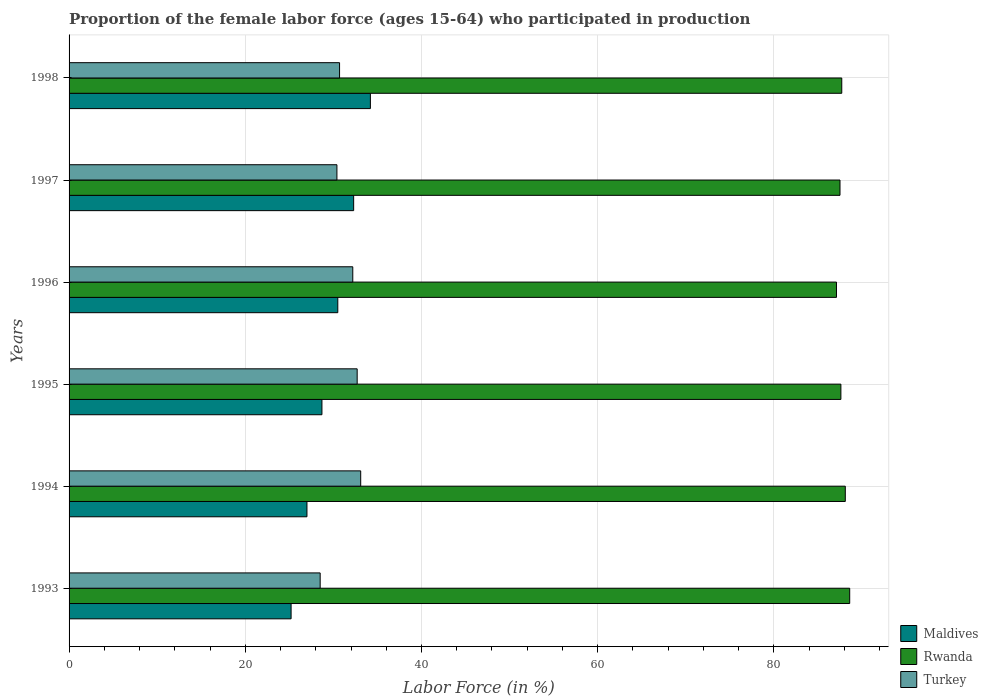How many different coloured bars are there?
Your answer should be compact. 3. How many groups of bars are there?
Provide a succinct answer. 6. What is the label of the 2nd group of bars from the top?
Make the answer very short. 1997. What is the proportion of the female labor force who participated in production in Maldives in 1993?
Offer a terse response. 25.2. Across all years, what is the maximum proportion of the female labor force who participated in production in Maldives?
Your response must be concise. 34.2. Across all years, what is the minimum proportion of the female labor force who participated in production in Turkey?
Provide a succinct answer. 28.5. In which year was the proportion of the female labor force who participated in production in Rwanda maximum?
Provide a short and direct response. 1993. In which year was the proportion of the female labor force who participated in production in Maldives minimum?
Keep it short and to the point. 1993. What is the total proportion of the female labor force who participated in production in Turkey in the graph?
Your answer should be very brief. 187.6. What is the difference between the proportion of the female labor force who participated in production in Turkey in 1995 and that in 1998?
Offer a very short reply. 2. What is the difference between the proportion of the female labor force who participated in production in Maldives in 1997 and the proportion of the female labor force who participated in production in Rwanda in 1998?
Provide a succinct answer. -55.4. What is the average proportion of the female labor force who participated in production in Maldives per year?
Your answer should be compact. 29.65. In the year 1998, what is the difference between the proportion of the female labor force who participated in production in Turkey and proportion of the female labor force who participated in production in Rwanda?
Offer a terse response. -57. In how many years, is the proportion of the female labor force who participated in production in Rwanda greater than 64 %?
Your answer should be very brief. 6. What is the ratio of the proportion of the female labor force who participated in production in Rwanda in 1993 to that in 1998?
Provide a succinct answer. 1.01. What is the difference between the highest and the second highest proportion of the female labor force who participated in production in Maldives?
Offer a terse response. 1.9. What is the difference between the highest and the lowest proportion of the female labor force who participated in production in Maldives?
Your answer should be compact. 9. In how many years, is the proportion of the female labor force who participated in production in Turkey greater than the average proportion of the female labor force who participated in production in Turkey taken over all years?
Your answer should be compact. 3. What does the 3rd bar from the top in 1994 represents?
Your answer should be compact. Maldives. What does the 1st bar from the bottom in 1994 represents?
Provide a succinct answer. Maldives. Is it the case that in every year, the sum of the proportion of the female labor force who participated in production in Maldives and proportion of the female labor force who participated in production in Turkey is greater than the proportion of the female labor force who participated in production in Rwanda?
Provide a short and direct response. No. How many bars are there?
Provide a short and direct response. 18. How many years are there in the graph?
Offer a very short reply. 6. What is the difference between two consecutive major ticks on the X-axis?
Your answer should be very brief. 20. Where does the legend appear in the graph?
Keep it short and to the point. Bottom right. How many legend labels are there?
Keep it short and to the point. 3. What is the title of the graph?
Your answer should be very brief. Proportion of the female labor force (ages 15-64) who participated in production. Does "Israel" appear as one of the legend labels in the graph?
Offer a terse response. No. What is the label or title of the Y-axis?
Your response must be concise. Years. What is the Labor Force (in %) in Maldives in 1993?
Provide a short and direct response. 25.2. What is the Labor Force (in %) of Rwanda in 1993?
Your answer should be very brief. 88.6. What is the Labor Force (in %) of Rwanda in 1994?
Ensure brevity in your answer.  88.1. What is the Labor Force (in %) of Turkey in 1994?
Offer a terse response. 33.1. What is the Labor Force (in %) in Maldives in 1995?
Ensure brevity in your answer.  28.7. What is the Labor Force (in %) in Rwanda in 1995?
Your answer should be very brief. 87.6. What is the Labor Force (in %) in Turkey in 1995?
Make the answer very short. 32.7. What is the Labor Force (in %) in Maldives in 1996?
Ensure brevity in your answer.  30.5. What is the Labor Force (in %) in Rwanda in 1996?
Your response must be concise. 87.1. What is the Labor Force (in %) of Turkey in 1996?
Your answer should be compact. 32.2. What is the Labor Force (in %) of Maldives in 1997?
Your response must be concise. 32.3. What is the Labor Force (in %) in Rwanda in 1997?
Give a very brief answer. 87.5. What is the Labor Force (in %) of Turkey in 1997?
Your answer should be very brief. 30.4. What is the Labor Force (in %) of Maldives in 1998?
Provide a short and direct response. 34.2. What is the Labor Force (in %) in Rwanda in 1998?
Your answer should be very brief. 87.7. What is the Labor Force (in %) of Turkey in 1998?
Your answer should be very brief. 30.7. Across all years, what is the maximum Labor Force (in %) in Maldives?
Your response must be concise. 34.2. Across all years, what is the maximum Labor Force (in %) of Rwanda?
Offer a very short reply. 88.6. Across all years, what is the maximum Labor Force (in %) in Turkey?
Offer a very short reply. 33.1. Across all years, what is the minimum Labor Force (in %) of Maldives?
Your answer should be compact. 25.2. Across all years, what is the minimum Labor Force (in %) of Rwanda?
Provide a short and direct response. 87.1. Across all years, what is the minimum Labor Force (in %) in Turkey?
Your response must be concise. 28.5. What is the total Labor Force (in %) of Maldives in the graph?
Make the answer very short. 177.9. What is the total Labor Force (in %) in Rwanda in the graph?
Offer a terse response. 526.6. What is the total Labor Force (in %) of Turkey in the graph?
Provide a short and direct response. 187.6. What is the difference between the Labor Force (in %) in Rwanda in 1993 and that in 1994?
Your answer should be compact. 0.5. What is the difference between the Labor Force (in %) of Turkey in 1993 and that in 1994?
Provide a short and direct response. -4.6. What is the difference between the Labor Force (in %) in Rwanda in 1993 and that in 1995?
Offer a terse response. 1. What is the difference between the Labor Force (in %) in Turkey in 1993 and that in 1995?
Offer a very short reply. -4.2. What is the difference between the Labor Force (in %) in Maldives in 1993 and that in 1996?
Make the answer very short. -5.3. What is the difference between the Labor Force (in %) in Maldives in 1993 and that in 1997?
Provide a short and direct response. -7.1. What is the difference between the Labor Force (in %) of Turkey in 1993 and that in 1997?
Give a very brief answer. -1.9. What is the difference between the Labor Force (in %) of Maldives in 1993 and that in 1998?
Keep it short and to the point. -9. What is the difference between the Labor Force (in %) of Turkey in 1993 and that in 1998?
Your answer should be compact. -2.2. What is the difference between the Labor Force (in %) of Maldives in 1994 and that in 1995?
Offer a very short reply. -1.7. What is the difference between the Labor Force (in %) in Rwanda in 1994 and that in 1995?
Give a very brief answer. 0.5. What is the difference between the Labor Force (in %) in Turkey in 1994 and that in 1996?
Provide a succinct answer. 0.9. What is the difference between the Labor Force (in %) of Maldives in 1994 and that in 1998?
Your answer should be very brief. -7.2. What is the difference between the Labor Force (in %) of Turkey in 1994 and that in 1998?
Provide a succinct answer. 2.4. What is the difference between the Labor Force (in %) of Rwanda in 1995 and that in 1997?
Keep it short and to the point. 0.1. What is the difference between the Labor Force (in %) of Turkey in 1995 and that in 1997?
Offer a terse response. 2.3. What is the difference between the Labor Force (in %) in Rwanda in 1995 and that in 1998?
Make the answer very short. -0.1. What is the difference between the Labor Force (in %) in Maldives in 1996 and that in 1997?
Provide a succinct answer. -1.8. What is the difference between the Labor Force (in %) of Turkey in 1996 and that in 1997?
Give a very brief answer. 1.8. What is the difference between the Labor Force (in %) of Turkey in 1996 and that in 1998?
Your answer should be very brief. 1.5. What is the difference between the Labor Force (in %) of Maldives in 1997 and that in 1998?
Offer a terse response. -1.9. What is the difference between the Labor Force (in %) in Rwanda in 1997 and that in 1998?
Your answer should be compact. -0.2. What is the difference between the Labor Force (in %) in Turkey in 1997 and that in 1998?
Provide a short and direct response. -0.3. What is the difference between the Labor Force (in %) of Maldives in 1993 and the Labor Force (in %) of Rwanda in 1994?
Offer a terse response. -62.9. What is the difference between the Labor Force (in %) in Rwanda in 1993 and the Labor Force (in %) in Turkey in 1994?
Provide a short and direct response. 55.5. What is the difference between the Labor Force (in %) of Maldives in 1993 and the Labor Force (in %) of Rwanda in 1995?
Ensure brevity in your answer.  -62.4. What is the difference between the Labor Force (in %) of Maldives in 1993 and the Labor Force (in %) of Turkey in 1995?
Offer a very short reply. -7.5. What is the difference between the Labor Force (in %) in Rwanda in 1993 and the Labor Force (in %) in Turkey in 1995?
Give a very brief answer. 55.9. What is the difference between the Labor Force (in %) of Maldives in 1993 and the Labor Force (in %) of Rwanda in 1996?
Provide a short and direct response. -61.9. What is the difference between the Labor Force (in %) of Rwanda in 1993 and the Labor Force (in %) of Turkey in 1996?
Provide a succinct answer. 56.4. What is the difference between the Labor Force (in %) in Maldives in 1993 and the Labor Force (in %) in Rwanda in 1997?
Offer a terse response. -62.3. What is the difference between the Labor Force (in %) in Rwanda in 1993 and the Labor Force (in %) in Turkey in 1997?
Ensure brevity in your answer.  58.2. What is the difference between the Labor Force (in %) of Maldives in 1993 and the Labor Force (in %) of Rwanda in 1998?
Offer a very short reply. -62.5. What is the difference between the Labor Force (in %) in Maldives in 1993 and the Labor Force (in %) in Turkey in 1998?
Your answer should be very brief. -5.5. What is the difference between the Labor Force (in %) in Rwanda in 1993 and the Labor Force (in %) in Turkey in 1998?
Ensure brevity in your answer.  57.9. What is the difference between the Labor Force (in %) of Maldives in 1994 and the Labor Force (in %) of Rwanda in 1995?
Provide a short and direct response. -60.6. What is the difference between the Labor Force (in %) of Maldives in 1994 and the Labor Force (in %) of Turkey in 1995?
Your answer should be compact. -5.7. What is the difference between the Labor Force (in %) of Rwanda in 1994 and the Labor Force (in %) of Turkey in 1995?
Give a very brief answer. 55.4. What is the difference between the Labor Force (in %) of Maldives in 1994 and the Labor Force (in %) of Rwanda in 1996?
Your answer should be compact. -60.1. What is the difference between the Labor Force (in %) of Maldives in 1994 and the Labor Force (in %) of Turkey in 1996?
Make the answer very short. -5.2. What is the difference between the Labor Force (in %) in Rwanda in 1994 and the Labor Force (in %) in Turkey in 1996?
Make the answer very short. 55.9. What is the difference between the Labor Force (in %) in Maldives in 1994 and the Labor Force (in %) in Rwanda in 1997?
Make the answer very short. -60.5. What is the difference between the Labor Force (in %) in Maldives in 1994 and the Labor Force (in %) in Turkey in 1997?
Provide a succinct answer. -3.4. What is the difference between the Labor Force (in %) in Rwanda in 1994 and the Labor Force (in %) in Turkey in 1997?
Offer a very short reply. 57.7. What is the difference between the Labor Force (in %) in Maldives in 1994 and the Labor Force (in %) in Rwanda in 1998?
Your response must be concise. -60.7. What is the difference between the Labor Force (in %) in Rwanda in 1994 and the Labor Force (in %) in Turkey in 1998?
Your answer should be compact. 57.4. What is the difference between the Labor Force (in %) in Maldives in 1995 and the Labor Force (in %) in Rwanda in 1996?
Ensure brevity in your answer.  -58.4. What is the difference between the Labor Force (in %) in Rwanda in 1995 and the Labor Force (in %) in Turkey in 1996?
Provide a short and direct response. 55.4. What is the difference between the Labor Force (in %) of Maldives in 1995 and the Labor Force (in %) of Rwanda in 1997?
Your response must be concise. -58.8. What is the difference between the Labor Force (in %) of Rwanda in 1995 and the Labor Force (in %) of Turkey in 1997?
Your response must be concise. 57.2. What is the difference between the Labor Force (in %) of Maldives in 1995 and the Labor Force (in %) of Rwanda in 1998?
Provide a short and direct response. -59. What is the difference between the Labor Force (in %) in Maldives in 1995 and the Labor Force (in %) in Turkey in 1998?
Keep it short and to the point. -2. What is the difference between the Labor Force (in %) in Rwanda in 1995 and the Labor Force (in %) in Turkey in 1998?
Make the answer very short. 56.9. What is the difference between the Labor Force (in %) of Maldives in 1996 and the Labor Force (in %) of Rwanda in 1997?
Offer a very short reply. -57. What is the difference between the Labor Force (in %) in Rwanda in 1996 and the Labor Force (in %) in Turkey in 1997?
Provide a short and direct response. 56.7. What is the difference between the Labor Force (in %) of Maldives in 1996 and the Labor Force (in %) of Rwanda in 1998?
Make the answer very short. -57.2. What is the difference between the Labor Force (in %) in Rwanda in 1996 and the Labor Force (in %) in Turkey in 1998?
Give a very brief answer. 56.4. What is the difference between the Labor Force (in %) of Maldives in 1997 and the Labor Force (in %) of Rwanda in 1998?
Ensure brevity in your answer.  -55.4. What is the difference between the Labor Force (in %) in Maldives in 1997 and the Labor Force (in %) in Turkey in 1998?
Provide a short and direct response. 1.6. What is the difference between the Labor Force (in %) in Rwanda in 1997 and the Labor Force (in %) in Turkey in 1998?
Ensure brevity in your answer.  56.8. What is the average Labor Force (in %) in Maldives per year?
Your answer should be very brief. 29.65. What is the average Labor Force (in %) in Rwanda per year?
Give a very brief answer. 87.77. What is the average Labor Force (in %) in Turkey per year?
Provide a short and direct response. 31.27. In the year 1993, what is the difference between the Labor Force (in %) of Maldives and Labor Force (in %) of Rwanda?
Keep it short and to the point. -63.4. In the year 1993, what is the difference between the Labor Force (in %) in Rwanda and Labor Force (in %) in Turkey?
Give a very brief answer. 60.1. In the year 1994, what is the difference between the Labor Force (in %) in Maldives and Labor Force (in %) in Rwanda?
Offer a terse response. -61.1. In the year 1995, what is the difference between the Labor Force (in %) of Maldives and Labor Force (in %) of Rwanda?
Make the answer very short. -58.9. In the year 1995, what is the difference between the Labor Force (in %) of Maldives and Labor Force (in %) of Turkey?
Ensure brevity in your answer.  -4. In the year 1995, what is the difference between the Labor Force (in %) of Rwanda and Labor Force (in %) of Turkey?
Keep it short and to the point. 54.9. In the year 1996, what is the difference between the Labor Force (in %) in Maldives and Labor Force (in %) in Rwanda?
Ensure brevity in your answer.  -56.6. In the year 1996, what is the difference between the Labor Force (in %) of Maldives and Labor Force (in %) of Turkey?
Give a very brief answer. -1.7. In the year 1996, what is the difference between the Labor Force (in %) of Rwanda and Labor Force (in %) of Turkey?
Keep it short and to the point. 54.9. In the year 1997, what is the difference between the Labor Force (in %) in Maldives and Labor Force (in %) in Rwanda?
Ensure brevity in your answer.  -55.2. In the year 1997, what is the difference between the Labor Force (in %) in Maldives and Labor Force (in %) in Turkey?
Provide a short and direct response. 1.9. In the year 1997, what is the difference between the Labor Force (in %) of Rwanda and Labor Force (in %) of Turkey?
Your answer should be compact. 57.1. In the year 1998, what is the difference between the Labor Force (in %) of Maldives and Labor Force (in %) of Rwanda?
Provide a short and direct response. -53.5. In the year 1998, what is the difference between the Labor Force (in %) in Rwanda and Labor Force (in %) in Turkey?
Your answer should be very brief. 57. What is the ratio of the Labor Force (in %) of Maldives in 1993 to that in 1994?
Keep it short and to the point. 0.93. What is the ratio of the Labor Force (in %) of Rwanda in 1993 to that in 1994?
Keep it short and to the point. 1.01. What is the ratio of the Labor Force (in %) in Turkey in 1993 to that in 1994?
Provide a succinct answer. 0.86. What is the ratio of the Labor Force (in %) of Maldives in 1993 to that in 1995?
Ensure brevity in your answer.  0.88. What is the ratio of the Labor Force (in %) of Rwanda in 1993 to that in 1995?
Offer a very short reply. 1.01. What is the ratio of the Labor Force (in %) in Turkey in 1993 to that in 1995?
Keep it short and to the point. 0.87. What is the ratio of the Labor Force (in %) of Maldives in 1993 to that in 1996?
Your answer should be compact. 0.83. What is the ratio of the Labor Force (in %) of Rwanda in 1993 to that in 1996?
Keep it short and to the point. 1.02. What is the ratio of the Labor Force (in %) of Turkey in 1993 to that in 1996?
Make the answer very short. 0.89. What is the ratio of the Labor Force (in %) in Maldives in 1993 to that in 1997?
Give a very brief answer. 0.78. What is the ratio of the Labor Force (in %) of Rwanda in 1993 to that in 1997?
Offer a terse response. 1.01. What is the ratio of the Labor Force (in %) in Maldives in 1993 to that in 1998?
Keep it short and to the point. 0.74. What is the ratio of the Labor Force (in %) of Rwanda in 1993 to that in 1998?
Provide a succinct answer. 1.01. What is the ratio of the Labor Force (in %) in Turkey in 1993 to that in 1998?
Offer a very short reply. 0.93. What is the ratio of the Labor Force (in %) in Maldives in 1994 to that in 1995?
Provide a short and direct response. 0.94. What is the ratio of the Labor Force (in %) of Turkey in 1994 to that in 1995?
Make the answer very short. 1.01. What is the ratio of the Labor Force (in %) in Maldives in 1994 to that in 1996?
Offer a very short reply. 0.89. What is the ratio of the Labor Force (in %) of Rwanda in 1994 to that in 1996?
Give a very brief answer. 1.01. What is the ratio of the Labor Force (in %) in Turkey in 1994 to that in 1996?
Provide a succinct answer. 1.03. What is the ratio of the Labor Force (in %) in Maldives in 1994 to that in 1997?
Offer a terse response. 0.84. What is the ratio of the Labor Force (in %) in Turkey in 1994 to that in 1997?
Offer a terse response. 1.09. What is the ratio of the Labor Force (in %) in Maldives in 1994 to that in 1998?
Your response must be concise. 0.79. What is the ratio of the Labor Force (in %) of Rwanda in 1994 to that in 1998?
Your answer should be very brief. 1. What is the ratio of the Labor Force (in %) of Turkey in 1994 to that in 1998?
Provide a succinct answer. 1.08. What is the ratio of the Labor Force (in %) in Maldives in 1995 to that in 1996?
Your answer should be compact. 0.94. What is the ratio of the Labor Force (in %) in Turkey in 1995 to that in 1996?
Provide a short and direct response. 1.02. What is the ratio of the Labor Force (in %) of Maldives in 1995 to that in 1997?
Your answer should be very brief. 0.89. What is the ratio of the Labor Force (in %) of Rwanda in 1995 to that in 1997?
Ensure brevity in your answer.  1. What is the ratio of the Labor Force (in %) in Turkey in 1995 to that in 1997?
Make the answer very short. 1.08. What is the ratio of the Labor Force (in %) of Maldives in 1995 to that in 1998?
Offer a very short reply. 0.84. What is the ratio of the Labor Force (in %) of Turkey in 1995 to that in 1998?
Keep it short and to the point. 1.07. What is the ratio of the Labor Force (in %) in Maldives in 1996 to that in 1997?
Keep it short and to the point. 0.94. What is the ratio of the Labor Force (in %) in Turkey in 1996 to that in 1997?
Your answer should be very brief. 1.06. What is the ratio of the Labor Force (in %) in Maldives in 1996 to that in 1998?
Provide a short and direct response. 0.89. What is the ratio of the Labor Force (in %) of Turkey in 1996 to that in 1998?
Keep it short and to the point. 1.05. What is the ratio of the Labor Force (in %) of Maldives in 1997 to that in 1998?
Your answer should be compact. 0.94. What is the ratio of the Labor Force (in %) of Rwanda in 1997 to that in 1998?
Your response must be concise. 1. What is the ratio of the Labor Force (in %) in Turkey in 1997 to that in 1998?
Your answer should be compact. 0.99. What is the difference between the highest and the second highest Labor Force (in %) of Maldives?
Ensure brevity in your answer.  1.9. What is the difference between the highest and the second highest Labor Force (in %) in Rwanda?
Give a very brief answer. 0.5. What is the difference between the highest and the second highest Labor Force (in %) in Turkey?
Your answer should be very brief. 0.4. What is the difference between the highest and the lowest Labor Force (in %) of Rwanda?
Keep it short and to the point. 1.5. 